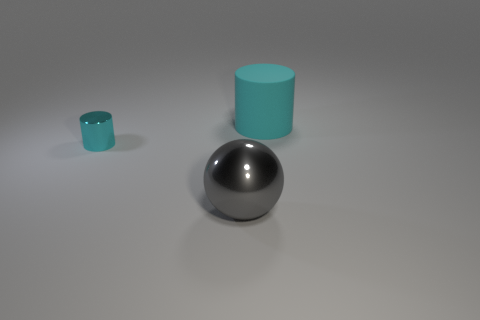Are there any other things that have the same shape as the gray thing?
Your answer should be compact. No. What shape is the thing that is the same material as the small cyan cylinder?
Give a very brief answer. Sphere. There is a object right of the gray sphere in front of the metallic thing to the left of the big metallic thing; what is its shape?
Your answer should be compact. Cylinder. Are there more small rubber spheres than tiny shiny cylinders?
Keep it short and to the point. No. What is the material of the other small thing that is the same shape as the cyan matte thing?
Keep it short and to the point. Metal. Is the material of the ball the same as the small cyan cylinder?
Give a very brief answer. Yes. Is the number of big cyan cylinders that are on the left side of the rubber object greater than the number of cylinders?
Your answer should be very brief. No. There is a cylinder that is behind the cyan object that is on the left side of the big cyan thing behind the small cyan thing; what is its material?
Your answer should be very brief. Rubber. How many things are either cylinders or things to the right of the tiny thing?
Your answer should be compact. 3. There is a large thing left of the matte cylinder; is its color the same as the big rubber object?
Offer a terse response. No. 